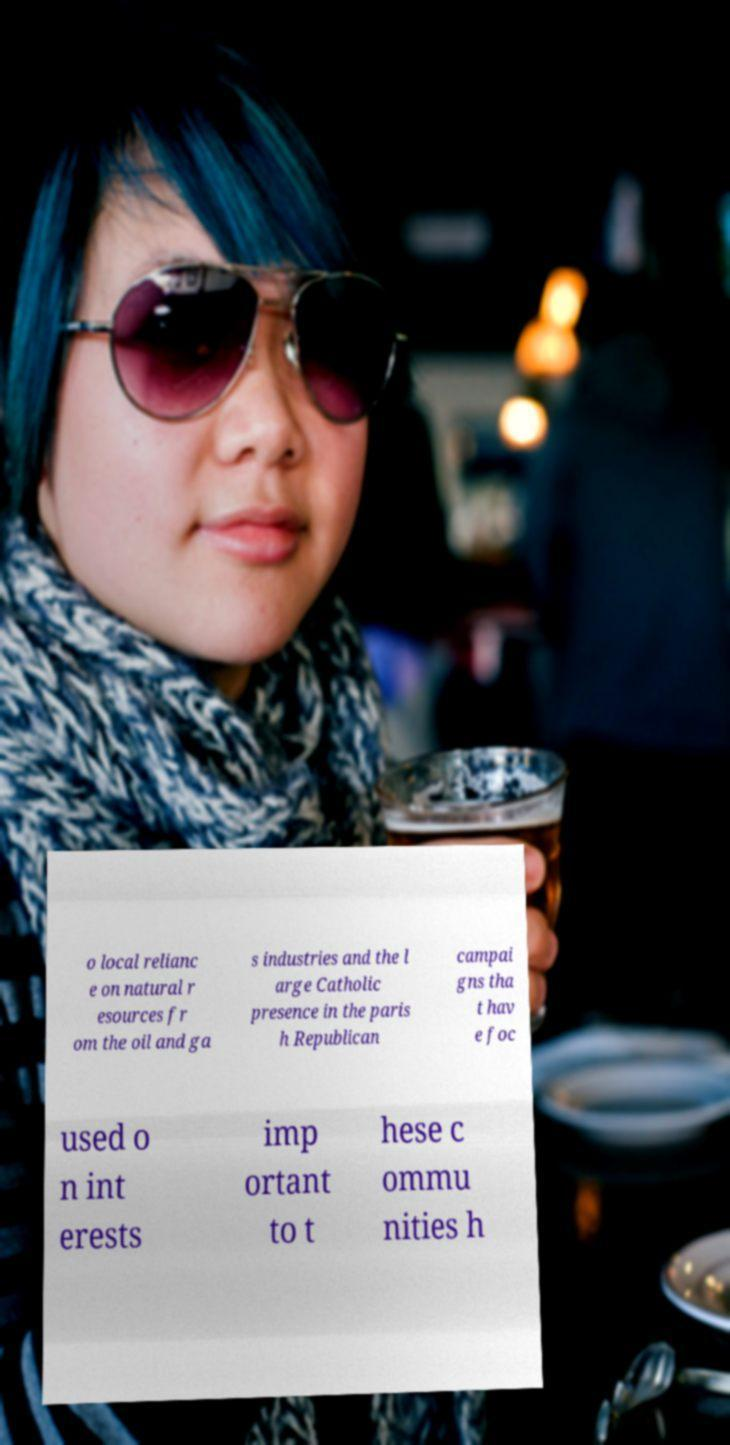I need the written content from this picture converted into text. Can you do that? o local relianc e on natural r esources fr om the oil and ga s industries and the l arge Catholic presence in the paris h Republican campai gns tha t hav e foc used o n int erests imp ortant to t hese c ommu nities h 